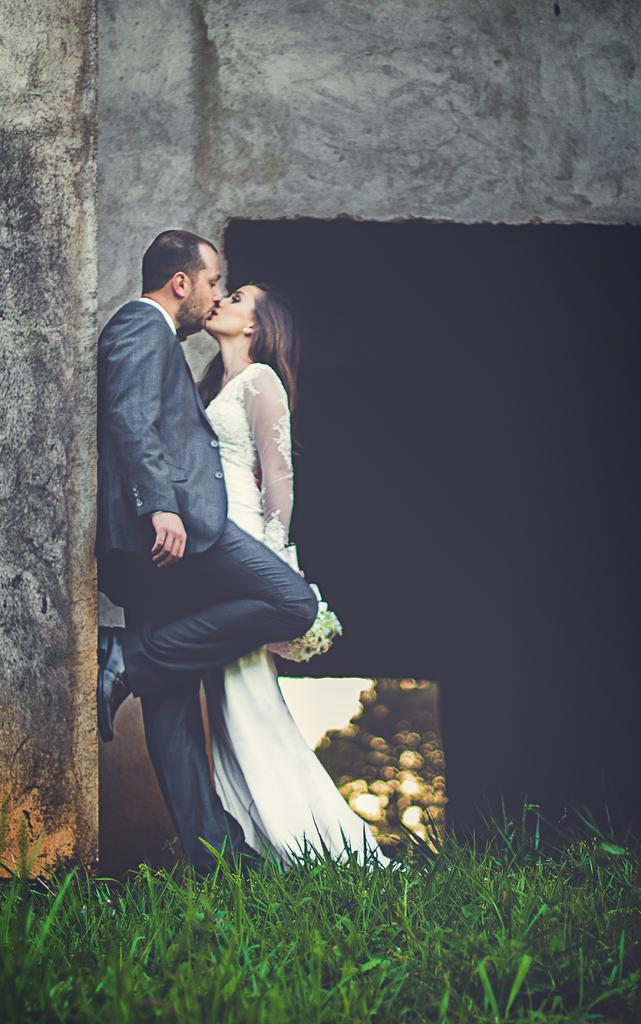What type of vegetation can be seen in the image? There is grass in the image. What structure is visible in the image? There is a wall in the image. How many people are present in the image? There are two people in the image. Can you describe the clothing of the woman in the image? The woman is wearing a white dress. How is the man dressed in the image? The man is wearing a blue jacket. What type of ice can be seen melting on the tramp in the image? There is no tramp or ice present in the image. Can you describe the running style of the woman in the image? There is no running depicted in the image; the woman is standing still. 